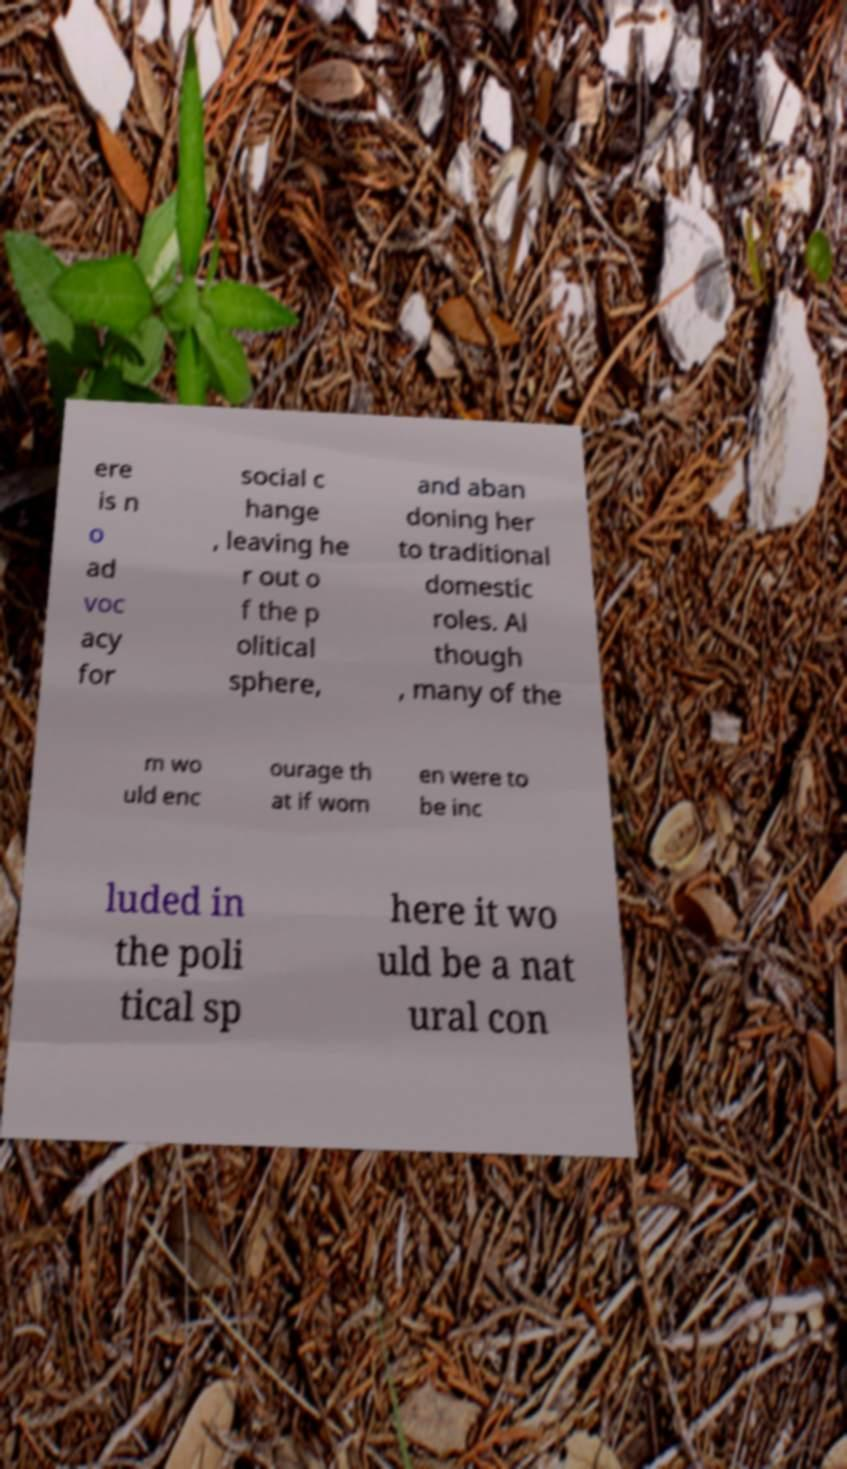What messages or text are displayed in this image? I need them in a readable, typed format. ere is n o ad voc acy for social c hange , leaving he r out o f the p olitical sphere, and aban doning her to traditional domestic roles. Al though , many of the m wo uld enc ourage th at if wom en were to be inc luded in the poli tical sp here it wo uld be a nat ural con 